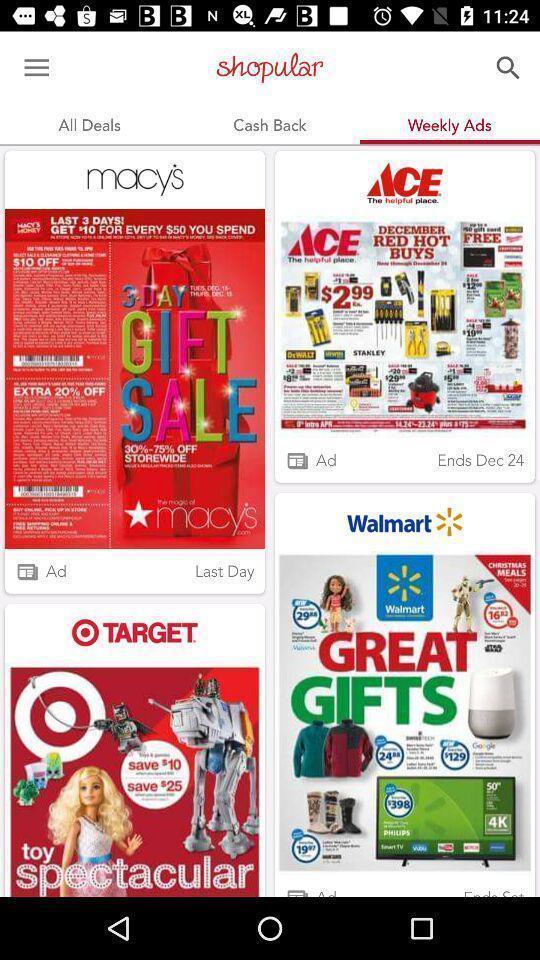What can you discern from this picture? Weekly advertisements page displaying. 